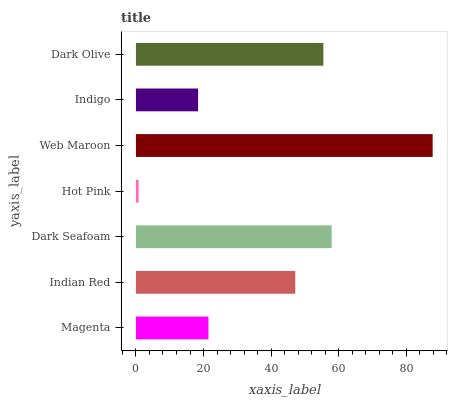Is Hot Pink the minimum?
Answer yes or no. Yes. Is Web Maroon the maximum?
Answer yes or no. Yes. Is Indian Red the minimum?
Answer yes or no. No. Is Indian Red the maximum?
Answer yes or no. No. Is Indian Red greater than Magenta?
Answer yes or no. Yes. Is Magenta less than Indian Red?
Answer yes or no. Yes. Is Magenta greater than Indian Red?
Answer yes or no. No. Is Indian Red less than Magenta?
Answer yes or no. No. Is Indian Red the high median?
Answer yes or no. Yes. Is Indian Red the low median?
Answer yes or no. Yes. Is Indigo the high median?
Answer yes or no. No. Is Hot Pink the low median?
Answer yes or no. No. 